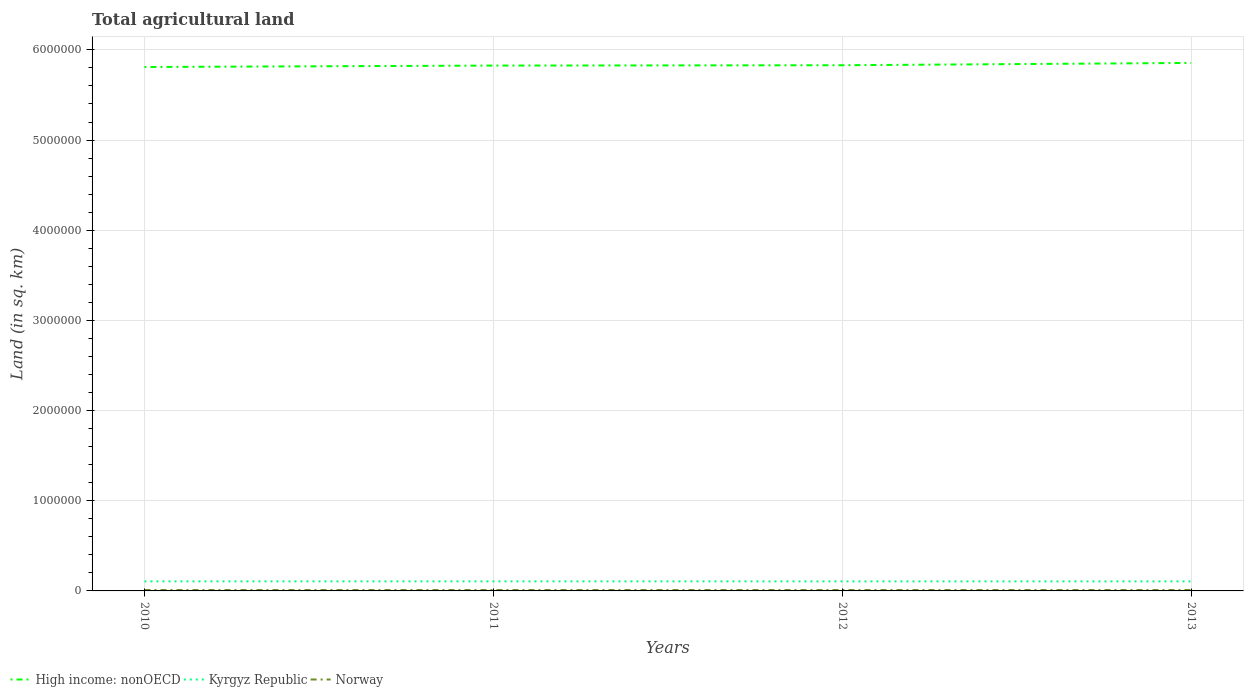How many different coloured lines are there?
Keep it short and to the point. 3. Does the line corresponding to Kyrgyz Republic intersect with the line corresponding to High income: nonOECD?
Keep it short and to the point. No. Across all years, what is the maximum total agricultural land in Norway?
Make the answer very short. 9872.1. What is the difference between the highest and the second highest total agricultural land in Kyrgyz Republic?
Give a very brief answer. 261. Is the total agricultural land in Norway strictly greater than the total agricultural land in High income: nonOECD over the years?
Your answer should be compact. Yes. What is the difference between two consecutive major ticks on the Y-axis?
Provide a short and direct response. 1.00e+06. Where does the legend appear in the graph?
Keep it short and to the point. Bottom left. How many legend labels are there?
Provide a succinct answer. 3. How are the legend labels stacked?
Your answer should be very brief. Horizontal. What is the title of the graph?
Your answer should be very brief. Total agricultural land. Does "Egypt, Arab Rep." appear as one of the legend labels in the graph?
Keep it short and to the point. No. What is the label or title of the X-axis?
Make the answer very short. Years. What is the label or title of the Y-axis?
Ensure brevity in your answer.  Land (in sq. km). What is the Land (in sq. km) of High income: nonOECD in 2010?
Your response must be concise. 5.81e+06. What is the Land (in sq. km) in Kyrgyz Republic in 2010?
Provide a succinct answer. 1.06e+05. What is the Land (in sq. km) of Norway in 2010?
Keep it short and to the point. 1.01e+04. What is the Land (in sq. km) in High income: nonOECD in 2011?
Give a very brief answer. 5.83e+06. What is the Land (in sq. km) in Kyrgyz Republic in 2011?
Your answer should be compact. 1.06e+05. What is the Land (in sq. km) in Norway in 2011?
Ensure brevity in your answer.  9990. What is the Land (in sq. km) in High income: nonOECD in 2012?
Your answer should be compact. 5.83e+06. What is the Land (in sq. km) in Kyrgyz Republic in 2012?
Offer a terse response. 1.06e+05. What is the Land (in sq. km) of Norway in 2012?
Provide a succinct answer. 9928. What is the Land (in sq. km) of High income: nonOECD in 2013?
Ensure brevity in your answer.  5.86e+06. What is the Land (in sq. km) in Kyrgyz Republic in 2013?
Give a very brief answer. 1.06e+05. What is the Land (in sq. km) in Norway in 2013?
Keep it short and to the point. 9872.1. Across all years, what is the maximum Land (in sq. km) of High income: nonOECD?
Offer a terse response. 5.86e+06. Across all years, what is the maximum Land (in sq. km) of Kyrgyz Republic?
Ensure brevity in your answer.  1.06e+05. Across all years, what is the maximum Land (in sq. km) of Norway?
Your answer should be very brief. 1.01e+04. Across all years, what is the minimum Land (in sq. km) of High income: nonOECD?
Offer a very short reply. 5.81e+06. Across all years, what is the minimum Land (in sq. km) of Kyrgyz Republic?
Provide a succinct answer. 1.06e+05. Across all years, what is the minimum Land (in sq. km) of Norway?
Ensure brevity in your answer.  9872.1. What is the total Land (in sq. km) of High income: nonOECD in the graph?
Keep it short and to the point. 2.33e+07. What is the total Land (in sq. km) in Kyrgyz Republic in the graph?
Provide a succinct answer. 4.24e+05. What is the total Land (in sq. km) of Norway in the graph?
Provide a short and direct response. 3.99e+04. What is the difference between the Land (in sq. km) in High income: nonOECD in 2010 and that in 2011?
Your answer should be very brief. -1.59e+04. What is the difference between the Land (in sq. km) of Kyrgyz Republic in 2010 and that in 2011?
Offer a very short reply. 34. What is the difference between the Land (in sq. km) in Norway in 2010 and that in 2011?
Give a very brief answer. 70. What is the difference between the Land (in sq. km) in High income: nonOECD in 2010 and that in 2012?
Make the answer very short. -1.96e+04. What is the difference between the Land (in sq. km) of Kyrgyz Republic in 2010 and that in 2012?
Provide a succinct answer. 206. What is the difference between the Land (in sq. km) in Norway in 2010 and that in 2012?
Your answer should be compact. 132. What is the difference between the Land (in sq. km) in High income: nonOECD in 2010 and that in 2013?
Provide a short and direct response. -4.51e+04. What is the difference between the Land (in sq. km) of Kyrgyz Republic in 2010 and that in 2013?
Your response must be concise. 261. What is the difference between the Land (in sq. km) in Norway in 2010 and that in 2013?
Provide a succinct answer. 187.9. What is the difference between the Land (in sq. km) in High income: nonOECD in 2011 and that in 2012?
Make the answer very short. -3718.9. What is the difference between the Land (in sq. km) of Kyrgyz Republic in 2011 and that in 2012?
Provide a succinct answer. 172. What is the difference between the Land (in sq. km) in Norway in 2011 and that in 2012?
Offer a terse response. 62. What is the difference between the Land (in sq. km) in High income: nonOECD in 2011 and that in 2013?
Provide a succinct answer. -2.93e+04. What is the difference between the Land (in sq. km) of Kyrgyz Republic in 2011 and that in 2013?
Make the answer very short. 227. What is the difference between the Land (in sq. km) of Norway in 2011 and that in 2013?
Offer a very short reply. 117.9. What is the difference between the Land (in sq. km) of High income: nonOECD in 2012 and that in 2013?
Ensure brevity in your answer.  -2.56e+04. What is the difference between the Land (in sq. km) in Norway in 2012 and that in 2013?
Provide a succinct answer. 55.9. What is the difference between the Land (in sq. km) in High income: nonOECD in 2010 and the Land (in sq. km) in Kyrgyz Republic in 2011?
Your answer should be very brief. 5.70e+06. What is the difference between the Land (in sq. km) in High income: nonOECD in 2010 and the Land (in sq. km) in Norway in 2011?
Make the answer very short. 5.80e+06. What is the difference between the Land (in sq. km) in Kyrgyz Republic in 2010 and the Land (in sq. km) in Norway in 2011?
Give a very brief answer. 9.61e+04. What is the difference between the Land (in sq. km) in High income: nonOECD in 2010 and the Land (in sq. km) in Kyrgyz Republic in 2012?
Your response must be concise. 5.70e+06. What is the difference between the Land (in sq. km) of High income: nonOECD in 2010 and the Land (in sq. km) of Norway in 2012?
Make the answer very short. 5.80e+06. What is the difference between the Land (in sq. km) of Kyrgyz Republic in 2010 and the Land (in sq. km) of Norway in 2012?
Ensure brevity in your answer.  9.62e+04. What is the difference between the Land (in sq. km) in High income: nonOECD in 2010 and the Land (in sq. km) in Kyrgyz Republic in 2013?
Provide a succinct answer. 5.70e+06. What is the difference between the Land (in sq. km) in High income: nonOECD in 2010 and the Land (in sq. km) in Norway in 2013?
Make the answer very short. 5.80e+06. What is the difference between the Land (in sq. km) of Kyrgyz Republic in 2010 and the Land (in sq. km) of Norway in 2013?
Offer a terse response. 9.62e+04. What is the difference between the Land (in sq. km) in High income: nonOECD in 2011 and the Land (in sq. km) in Kyrgyz Republic in 2012?
Ensure brevity in your answer.  5.72e+06. What is the difference between the Land (in sq. km) of High income: nonOECD in 2011 and the Land (in sq. km) of Norway in 2012?
Make the answer very short. 5.82e+06. What is the difference between the Land (in sq. km) in Kyrgyz Republic in 2011 and the Land (in sq. km) in Norway in 2012?
Your answer should be compact. 9.62e+04. What is the difference between the Land (in sq. km) of High income: nonOECD in 2011 and the Land (in sq. km) of Kyrgyz Republic in 2013?
Keep it short and to the point. 5.72e+06. What is the difference between the Land (in sq. km) of High income: nonOECD in 2011 and the Land (in sq. km) of Norway in 2013?
Keep it short and to the point. 5.82e+06. What is the difference between the Land (in sq. km) in Kyrgyz Republic in 2011 and the Land (in sq. km) in Norway in 2013?
Provide a short and direct response. 9.62e+04. What is the difference between the Land (in sq. km) of High income: nonOECD in 2012 and the Land (in sq. km) of Kyrgyz Republic in 2013?
Your answer should be very brief. 5.72e+06. What is the difference between the Land (in sq. km) of High income: nonOECD in 2012 and the Land (in sq. km) of Norway in 2013?
Ensure brevity in your answer.  5.82e+06. What is the difference between the Land (in sq. km) of Kyrgyz Republic in 2012 and the Land (in sq. km) of Norway in 2013?
Your answer should be very brief. 9.60e+04. What is the average Land (in sq. km) in High income: nonOECD per year?
Keep it short and to the point. 5.83e+06. What is the average Land (in sq. km) of Kyrgyz Republic per year?
Your answer should be compact. 1.06e+05. What is the average Land (in sq. km) in Norway per year?
Provide a succinct answer. 9962.52. In the year 2010, what is the difference between the Land (in sq. km) in High income: nonOECD and Land (in sq. km) in Kyrgyz Republic?
Keep it short and to the point. 5.70e+06. In the year 2010, what is the difference between the Land (in sq. km) in High income: nonOECD and Land (in sq. km) in Norway?
Your response must be concise. 5.80e+06. In the year 2010, what is the difference between the Land (in sq. km) in Kyrgyz Republic and Land (in sq. km) in Norway?
Your answer should be very brief. 9.61e+04. In the year 2011, what is the difference between the Land (in sq. km) in High income: nonOECD and Land (in sq. km) in Kyrgyz Republic?
Your answer should be compact. 5.72e+06. In the year 2011, what is the difference between the Land (in sq. km) in High income: nonOECD and Land (in sq. km) in Norway?
Make the answer very short. 5.82e+06. In the year 2011, what is the difference between the Land (in sq. km) of Kyrgyz Republic and Land (in sq. km) of Norway?
Your answer should be compact. 9.61e+04. In the year 2012, what is the difference between the Land (in sq. km) in High income: nonOECD and Land (in sq. km) in Kyrgyz Republic?
Offer a terse response. 5.72e+06. In the year 2012, what is the difference between the Land (in sq. km) of High income: nonOECD and Land (in sq. km) of Norway?
Your answer should be compact. 5.82e+06. In the year 2012, what is the difference between the Land (in sq. km) in Kyrgyz Republic and Land (in sq. km) in Norway?
Make the answer very short. 9.60e+04. In the year 2013, what is the difference between the Land (in sq. km) in High income: nonOECD and Land (in sq. km) in Kyrgyz Republic?
Make the answer very short. 5.75e+06. In the year 2013, what is the difference between the Land (in sq. km) of High income: nonOECD and Land (in sq. km) of Norway?
Provide a succinct answer. 5.85e+06. In the year 2013, what is the difference between the Land (in sq. km) in Kyrgyz Republic and Land (in sq. km) in Norway?
Your answer should be compact. 9.60e+04. What is the ratio of the Land (in sq. km) in Kyrgyz Republic in 2010 to that in 2011?
Your response must be concise. 1. What is the ratio of the Land (in sq. km) of High income: nonOECD in 2010 to that in 2012?
Give a very brief answer. 1. What is the ratio of the Land (in sq. km) of Kyrgyz Republic in 2010 to that in 2012?
Provide a succinct answer. 1. What is the ratio of the Land (in sq. km) in Norway in 2010 to that in 2012?
Provide a succinct answer. 1.01. What is the ratio of the Land (in sq. km) of High income: nonOECD in 2010 to that in 2013?
Provide a succinct answer. 0.99. What is the ratio of the Land (in sq. km) in Kyrgyz Republic in 2010 to that in 2013?
Ensure brevity in your answer.  1. What is the ratio of the Land (in sq. km) of Norway in 2010 to that in 2013?
Make the answer very short. 1.02. What is the ratio of the Land (in sq. km) of High income: nonOECD in 2011 to that in 2012?
Provide a short and direct response. 1. What is the ratio of the Land (in sq. km) in Norway in 2011 to that in 2012?
Your answer should be compact. 1.01. What is the ratio of the Land (in sq. km) in High income: nonOECD in 2011 to that in 2013?
Your answer should be compact. 0.99. What is the ratio of the Land (in sq. km) of Norway in 2011 to that in 2013?
Offer a terse response. 1.01. What is the ratio of the Land (in sq. km) of High income: nonOECD in 2012 to that in 2013?
Ensure brevity in your answer.  1. What is the ratio of the Land (in sq. km) in Norway in 2012 to that in 2013?
Keep it short and to the point. 1.01. What is the difference between the highest and the second highest Land (in sq. km) of High income: nonOECD?
Offer a terse response. 2.56e+04. What is the difference between the highest and the second highest Land (in sq. km) in Kyrgyz Republic?
Ensure brevity in your answer.  34. What is the difference between the highest and the second highest Land (in sq. km) of Norway?
Your answer should be compact. 70. What is the difference between the highest and the lowest Land (in sq. km) in High income: nonOECD?
Your response must be concise. 4.51e+04. What is the difference between the highest and the lowest Land (in sq. km) in Kyrgyz Republic?
Your answer should be very brief. 261. What is the difference between the highest and the lowest Land (in sq. km) in Norway?
Give a very brief answer. 187.9. 